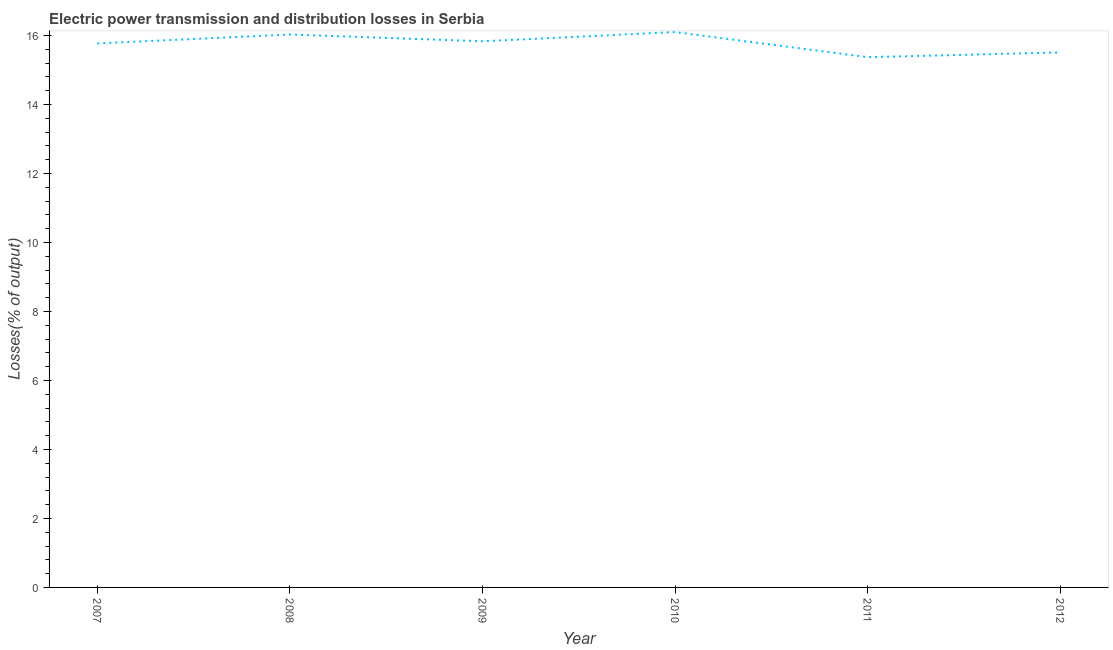What is the electric power transmission and distribution losses in 2009?
Your answer should be compact. 15.83. Across all years, what is the maximum electric power transmission and distribution losses?
Provide a short and direct response. 16.1. Across all years, what is the minimum electric power transmission and distribution losses?
Provide a short and direct response. 15.37. What is the sum of the electric power transmission and distribution losses?
Make the answer very short. 94.6. What is the difference between the electric power transmission and distribution losses in 2007 and 2008?
Provide a succinct answer. -0.26. What is the average electric power transmission and distribution losses per year?
Provide a succinct answer. 15.77. What is the median electric power transmission and distribution losses?
Offer a terse response. 15.8. In how many years, is the electric power transmission and distribution losses greater than 10.8 %?
Provide a short and direct response. 6. Do a majority of the years between 2010 and 2008 (inclusive) have electric power transmission and distribution losses greater than 13.6 %?
Make the answer very short. No. What is the ratio of the electric power transmission and distribution losses in 2008 to that in 2010?
Make the answer very short. 1. Is the electric power transmission and distribution losses in 2008 less than that in 2011?
Give a very brief answer. No. What is the difference between the highest and the second highest electric power transmission and distribution losses?
Give a very brief answer. 0.07. What is the difference between the highest and the lowest electric power transmission and distribution losses?
Offer a very short reply. 0.73. In how many years, is the electric power transmission and distribution losses greater than the average electric power transmission and distribution losses taken over all years?
Keep it short and to the point. 4. Does the electric power transmission and distribution losses monotonically increase over the years?
Keep it short and to the point. No. What is the difference between two consecutive major ticks on the Y-axis?
Make the answer very short. 2. Does the graph contain any zero values?
Your answer should be very brief. No. What is the title of the graph?
Your answer should be compact. Electric power transmission and distribution losses in Serbia. What is the label or title of the Y-axis?
Your answer should be very brief. Losses(% of output). What is the Losses(% of output) of 2007?
Your answer should be very brief. 15.77. What is the Losses(% of output) in 2008?
Your answer should be very brief. 16.03. What is the Losses(% of output) of 2009?
Keep it short and to the point. 15.83. What is the Losses(% of output) of 2010?
Make the answer very short. 16.1. What is the Losses(% of output) of 2011?
Your response must be concise. 15.37. What is the Losses(% of output) of 2012?
Your answer should be very brief. 15.51. What is the difference between the Losses(% of output) in 2007 and 2008?
Your answer should be very brief. -0.26. What is the difference between the Losses(% of output) in 2007 and 2009?
Make the answer very short. -0.06. What is the difference between the Losses(% of output) in 2007 and 2010?
Make the answer very short. -0.33. What is the difference between the Losses(% of output) in 2007 and 2011?
Your answer should be very brief. 0.4. What is the difference between the Losses(% of output) in 2007 and 2012?
Give a very brief answer. 0.26. What is the difference between the Losses(% of output) in 2008 and 2009?
Give a very brief answer. 0.2. What is the difference between the Losses(% of output) in 2008 and 2010?
Make the answer very short. -0.07. What is the difference between the Losses(% of output) in 2008 and 2011?
Your answer should be very brief. 0.66. What is the difference between the Losses(% of output) in 2008 and 2012?
Your response must be concise. 0.52. What is the difference between the Losses(% of output) in 2009 and 2010?
Keep it short and to the point. -0.27. What is the difference between the Losses(% of output) in 2009 and 2011?
Provide a short and direct response. 0.46. What is the difference between the Losses(% of output) in 2009 and 2012?
Provide a short and direct response. 0.32. What is the difference between the Losses(% of output) in 2010 and 2011?
Keep it short and to the point. 0.73. What is the difference between the Losses(% of output) in 2010 and 2012?
Your answer should be very brief. 0.59. What is the difference between the Losses(% of output) in 2011 and 2012?
Give a very brief answer. -0.14. What is the ratio of the Losses(% of output) in 2007 to that in 2010?
Offer a terse response. 0.98. What is the ratio of the Losses(% of output) in 2007 to that in 2011?
Offer a terse response. 1.03. What is the ratio of the Losses(% of output) in 2007 to that in 2012?
Ensure brevity in your answer.  1.02. What is the ratio of the Losses(% of output) in 2008 to that in 2009?
Offer a terse response. 1.01. What is the ratio of the Losses(% of output) in 2008 to that in 2010?
Provide a succinct answer. 1. What is the ratio of the Losses(% of output) in 2008 to that in 2011?
Keep it short and to the point. 1.04. What is the ratio of the Losses(% of output) in 2008 to that in 2012?
Keep it short and to the point. 1.03. What is the ratio of the Losses(% of output) in 2009 to that in 2010?
Keep it short and to the point. 0.98. What is the ratio of the Losses(% of output) in 2010 to that in 2011?
Provide a short and direct response. 1.05. What is the ratio of the Losses(% of output) in 2010 to that in 2012?
Offer a very short reply. 1.04. 